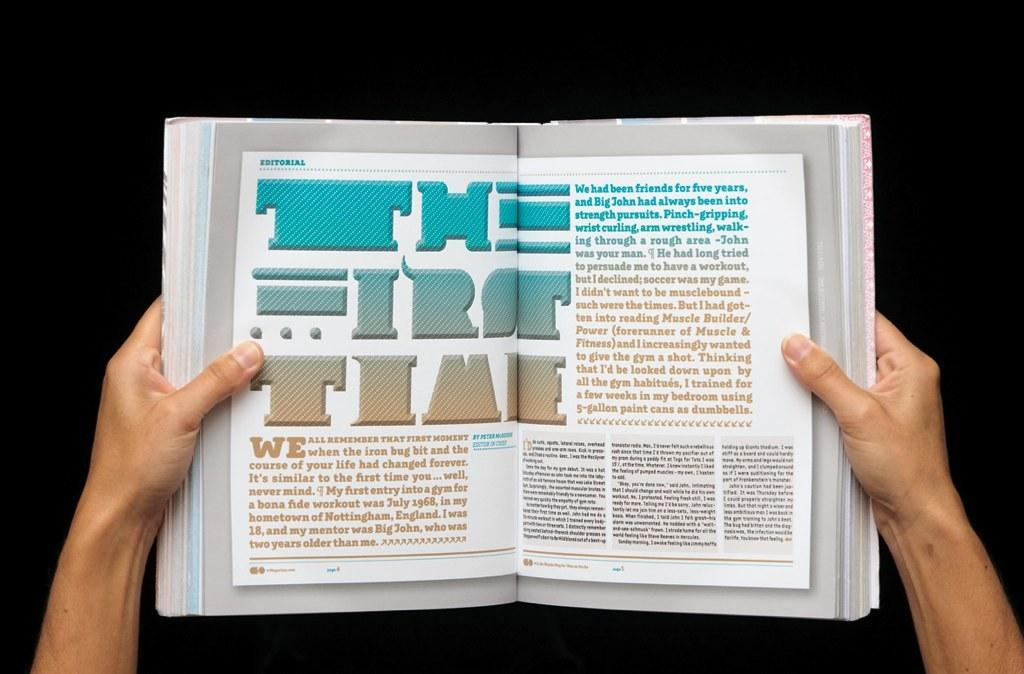<image>
Write a terse but informative summary of the picture. The first time book that is open in on the editorial section. 